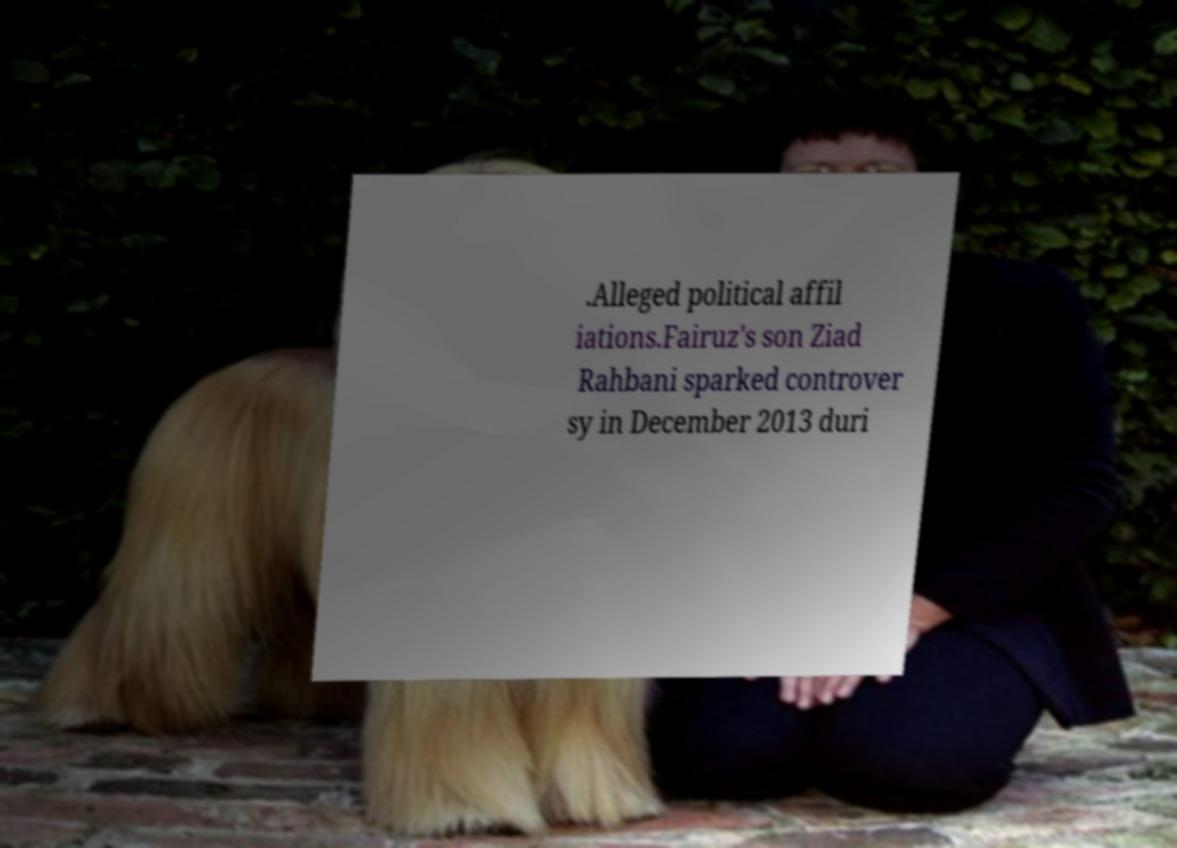I need the written content from this picture converted into text. Can you do that? .Alleged political affil iations.Fairuz's son Ziad Rahbani sparked controver sy in December 2013 duri 